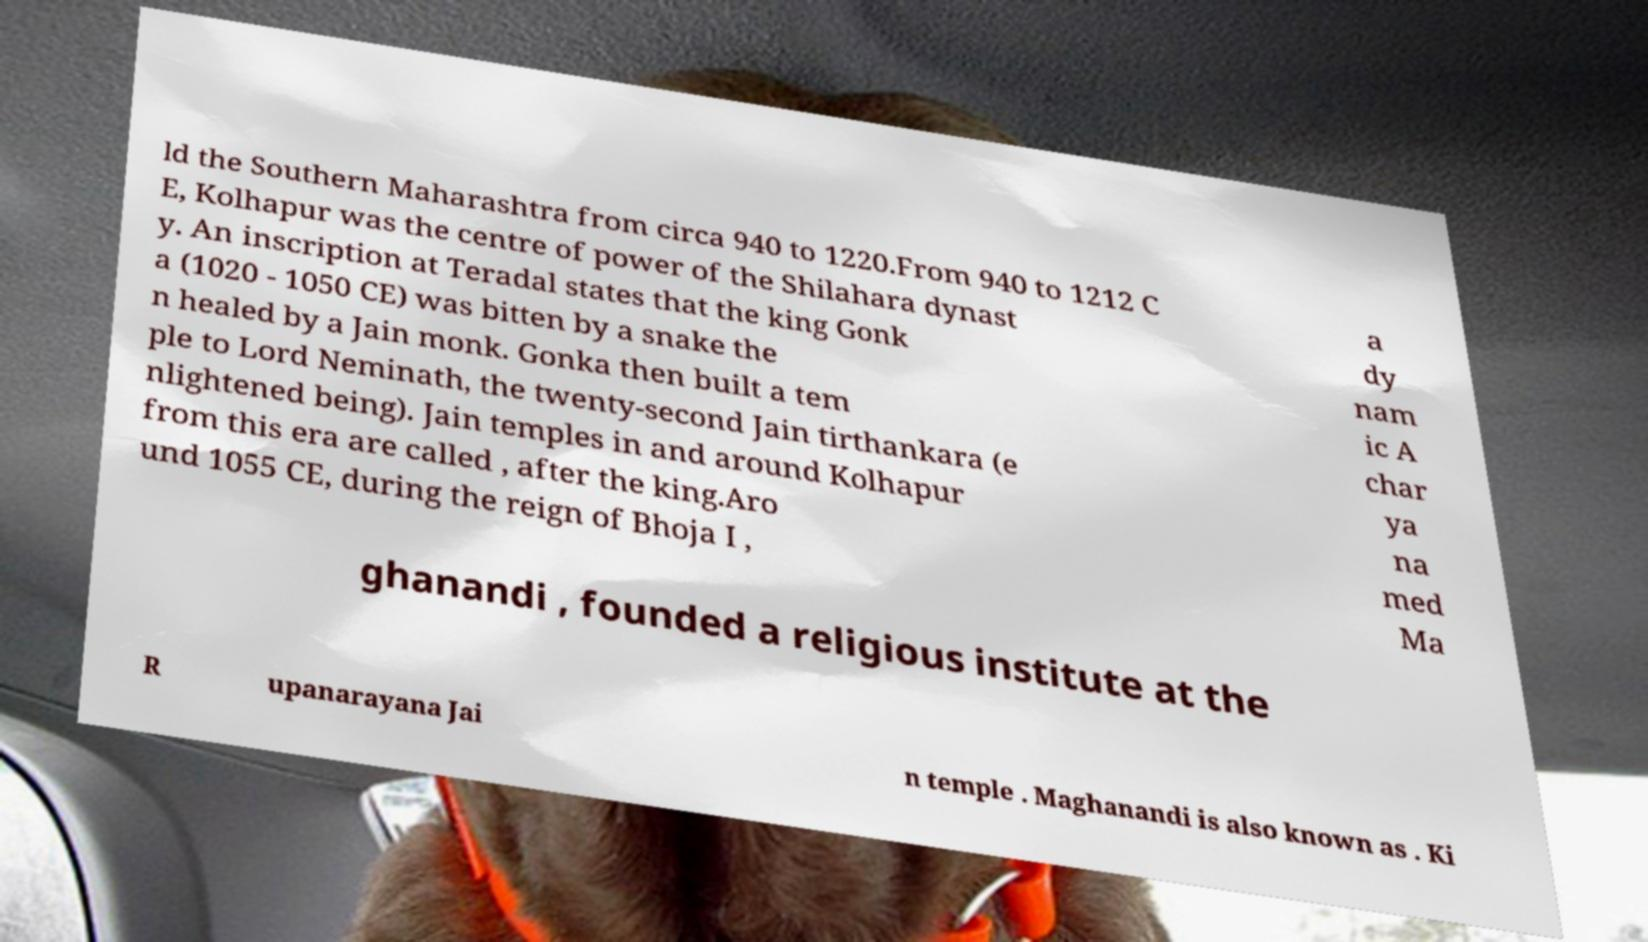Can you accurately transcribe the text from the provided image for me? ld the Southern Maharashtra from circa 940 to 1220.From 940 to 1212 C E, Kolhapur was the centre of power of the Shilahara dynast y. An inscription at Teradal states that the king Gonk a (1020 - 1050 CE) was bitten by a snake the n healed by a Jain monk. Gonka then built a tem ple to Lord Neminath, the twenty-second Jain tirthankara (e nlightened being). Jain temples in and around Kolhapur from this era are called , after the king.Aro und 1055 CE, during the reign of Bhoja I , a dy nam ic A char ya na med Ma ghanandi , founded a religious institute at the R upanarayana Jai n temple . Maghanandi is also known as . Ki 